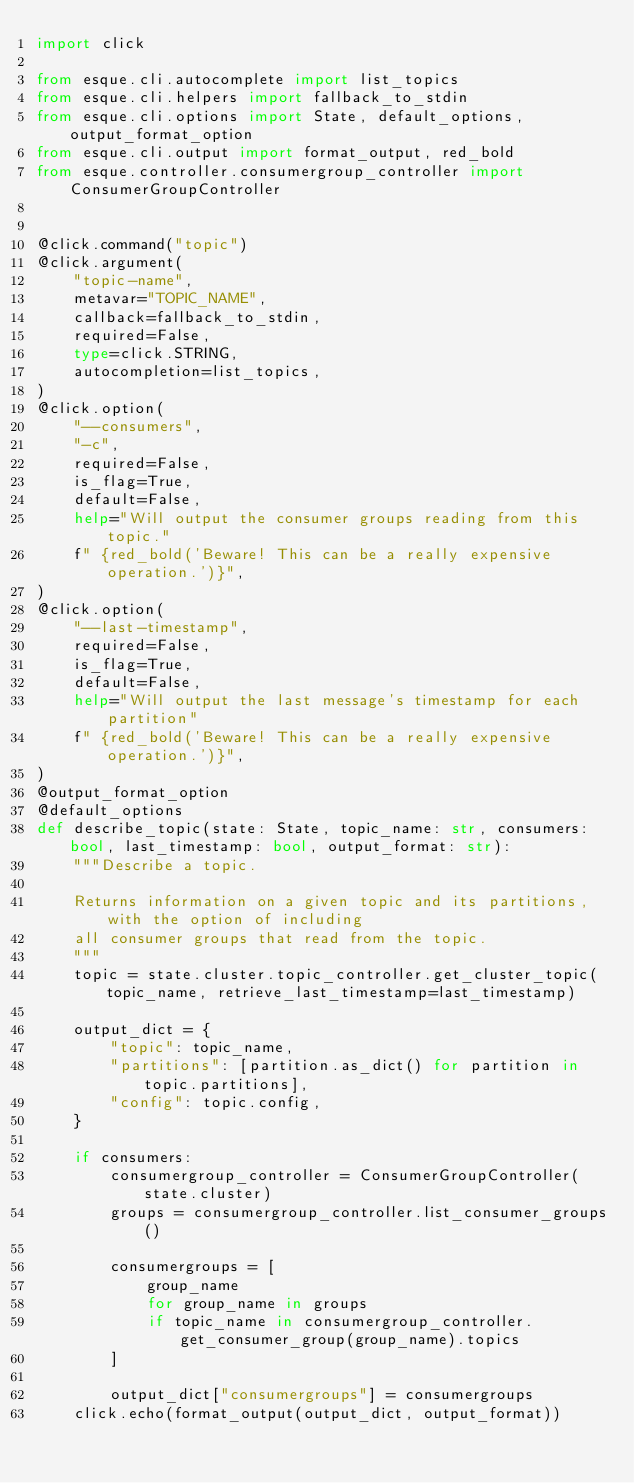<code> <loc_0><loc_0><loc_500><loc_500><_Python_>import click

from esque.cli.autocomplete import list_topics
from esque.cli.helpers import fallback_to_stdin
from esque.cli.options import State, default_options, output_format_option
from esque.cli.output import format_output, red_bold
from esque.controller.consumergroup_controller import ConsumerGroupController


@click.command("topic")
@click.argument(
    "topic-name",
    metavar="TOPIC_NAME",
    callback=fallback_to_stdin,
    required=False,
    type=click.STRING,
    autocompletion=list_topics,
)
@click.option(
    "--consumers",
    "-c",
    required=False,
    is_flag=True,
    default=False,
    help="Will output the consumer groups reading from this topic."
    f" {red_bold('Beware! This can be a really expensive operation.')}",
)
@click.option(
    "--last-timestamp",
    required=False,
    is_flag=True,
    default=False,
    help="Will output the last message's timestamp for each partition"
    f" {red_bold('Beware! This can be a really expensive operation.')}",
)
@output_format_option
@default_options
def describe_topic(state: State, topic_name: str, consumers: bool, last_timestamp: bool, output_format: str):
    """Describe a topic.

    Returns information on a given topic and its partitions, with the option of including
    all consumer groups that read from the topic.
    """
    topic = state.cluster.topic_controller.get_cluster_topic(topic_name, retrieve_last_timestamp=last_timestamp)

    output_dict = {
        "topic": topic_name,
        "partitions": [partition.as_dict() for partition in topic.partitions],
        "config": topic.config,
    }

    if consumers:
        consumergroup_controller = ConsumerGroupController(state.cluster)
        groups = consumergroup_controller.list_consumer_groups()

        consumergroups = [
            group_name
            for group_name in groups
            if topic_name in consumergroup_controller.get_consumer_group(group_name).topics
        ]

        output_dict["consumergroups"] = consumergroups
    click.echo(format_output(output_dict, output_format))
</code> 